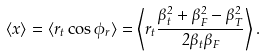<formula> <loc_0><loc_0><loc_500><loc_500>\langle x \rangle = \langle r _ { t } \cos \phi _ { r } \rangle = \left \langle r _ { t } \frac { \beta _ { t } ^ { 2 } + \beta _ { F } ^ { 2 } - \beta _ { T } ^ { 2 } } { 2 \beta _ { t } \beta _ { F } } \right \rangle .</formula> 